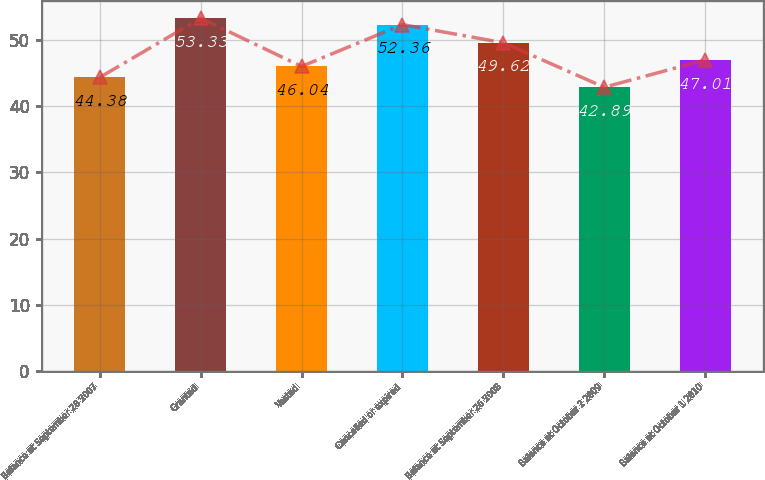Convert chart to OTSL. <chart><loc_0><loc_0><loc_500><loc_500><bar_chart><fcel>Balance at September 28 2007<fcel>Granted<fcel>Vested<fcel>Cancelled or expired<fcel>Balance at September 26 2008<fcel>Balance at October 2 2009<fcel>Balance at October 1 2010<nl><fcel>44.38<fcel>53.33<fcel>46.04<fcel>52.36<fcel>49.62<fcel>42.89<fcel>47.01<nl></chart> 